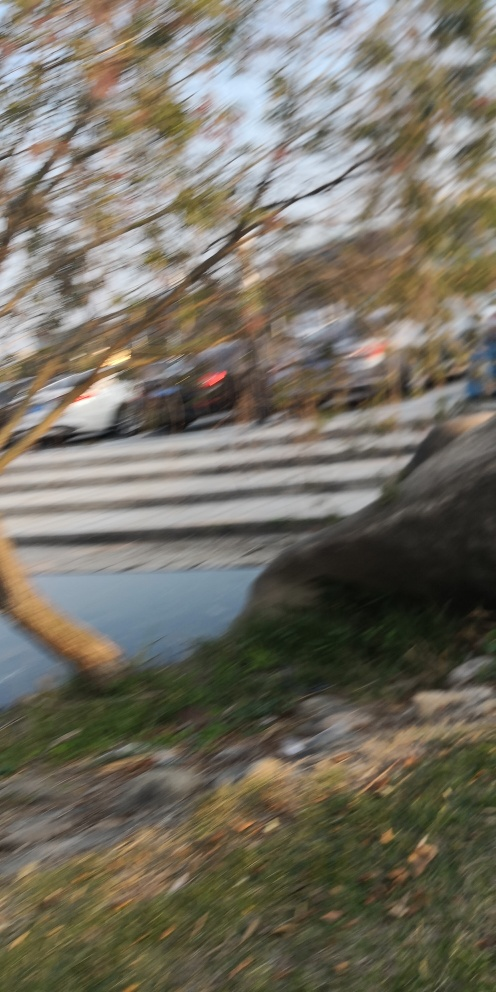Is there anything in the image that you can identify despite the blurriness? Despite the blurriness, you can make out some elements, such as the presence of trees, patches of grass, and what appears to be a road or street. There seem to be vehicles on the road, but individual details are indiscernible due to the lack of focus. 